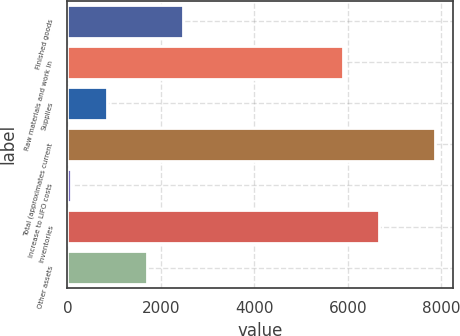Convert chart. <chart><loc_0><loc_0><loc_500><loc_500><bar_chart><fcel>Finished goods<fcel>Raw materials and work in<fcel>Supplies<fcel>Total (approximates current<fcel>Increase to LIFO costs<fcel>Inventories<fcel>Other assets<nl><fcel>2482.4<fcel>5894<fcel>851.4<fcel>7857<fcel>73<fcel>6672.4<fcel>1704<nl></chart> 